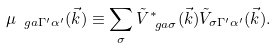<formula> <loc_0><loc_0><loc_500><loc_500>\mu _ { \ g a \Gamma ^ { \prime } \alpha ^ { \prime } } ( \vec { k } ) \equiv \sum _ { \sigma } \tilde { V } ^ { * } _ { \ g a \sigma } ( \vec { k } ) \tilde { V } _ { \sigma \Gamma ^ { \prime } \alpha ^ { \prime } } ( \vec { k } ) .</formula> 